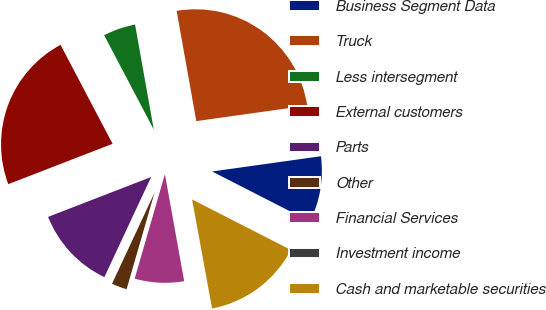<chart> <loc_0><loc_0><loc_500><loc_500><pie_chart><fcel>Business Segment Data<fcel>Truck<fcel>Less intersegment<fcel>External customers<fcel>Parts<fcel>Other<fcel>Financial Services<fcel>Investment income<fcel>Cash and marketable securities<nl><fcel>9.74%<fcel>25.59%<fcel>4.9%<fcel>23.17%<fcel>12.17%<fcel>2.47%<fcel>7.32%<fcel>0.05%<fcel>14.59%<nl></chart> 